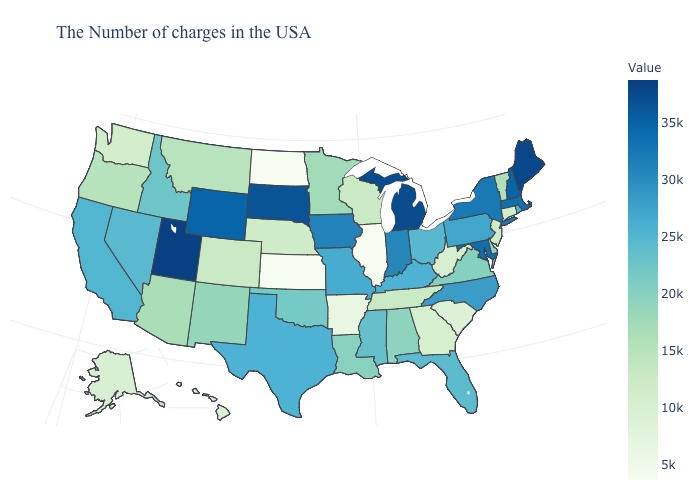Does Rhode Island have a higher value than Louisiana?
Quick response, please. Yes. Does the map have missing data?
Answer briefly. No. Does the map have missing data?
Be succinct. No. Does Alaska have a higher value than Illinois?
Concise answer only. Yes. Which states have the highest value in the USA?
Be succinct. Utah. Is the legend a continuous bar?
Concise answer only. Yes. Among the states that border Nevada , which have the highest value?
Keep it brief. Utah. Does Utah have the highest value in the USA?
Answer briefly. Yes. Does the map have missing data?
Keep it brief. No. 